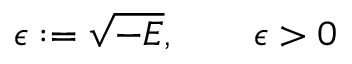<formula> <loc_0><loc_0><loc_500><loc_500>\epsilon \colon = \sqrt { - E } , \quad \epsilon > 0</formula> 